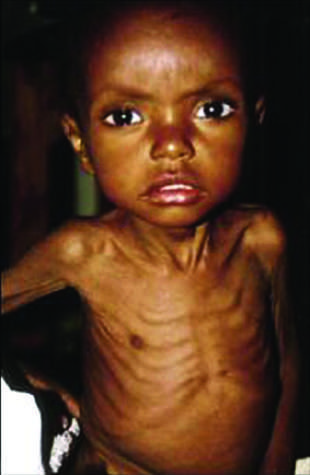what does the head appear to be?
Answer the question using a single word or phrase. Too large for the emaciated body 